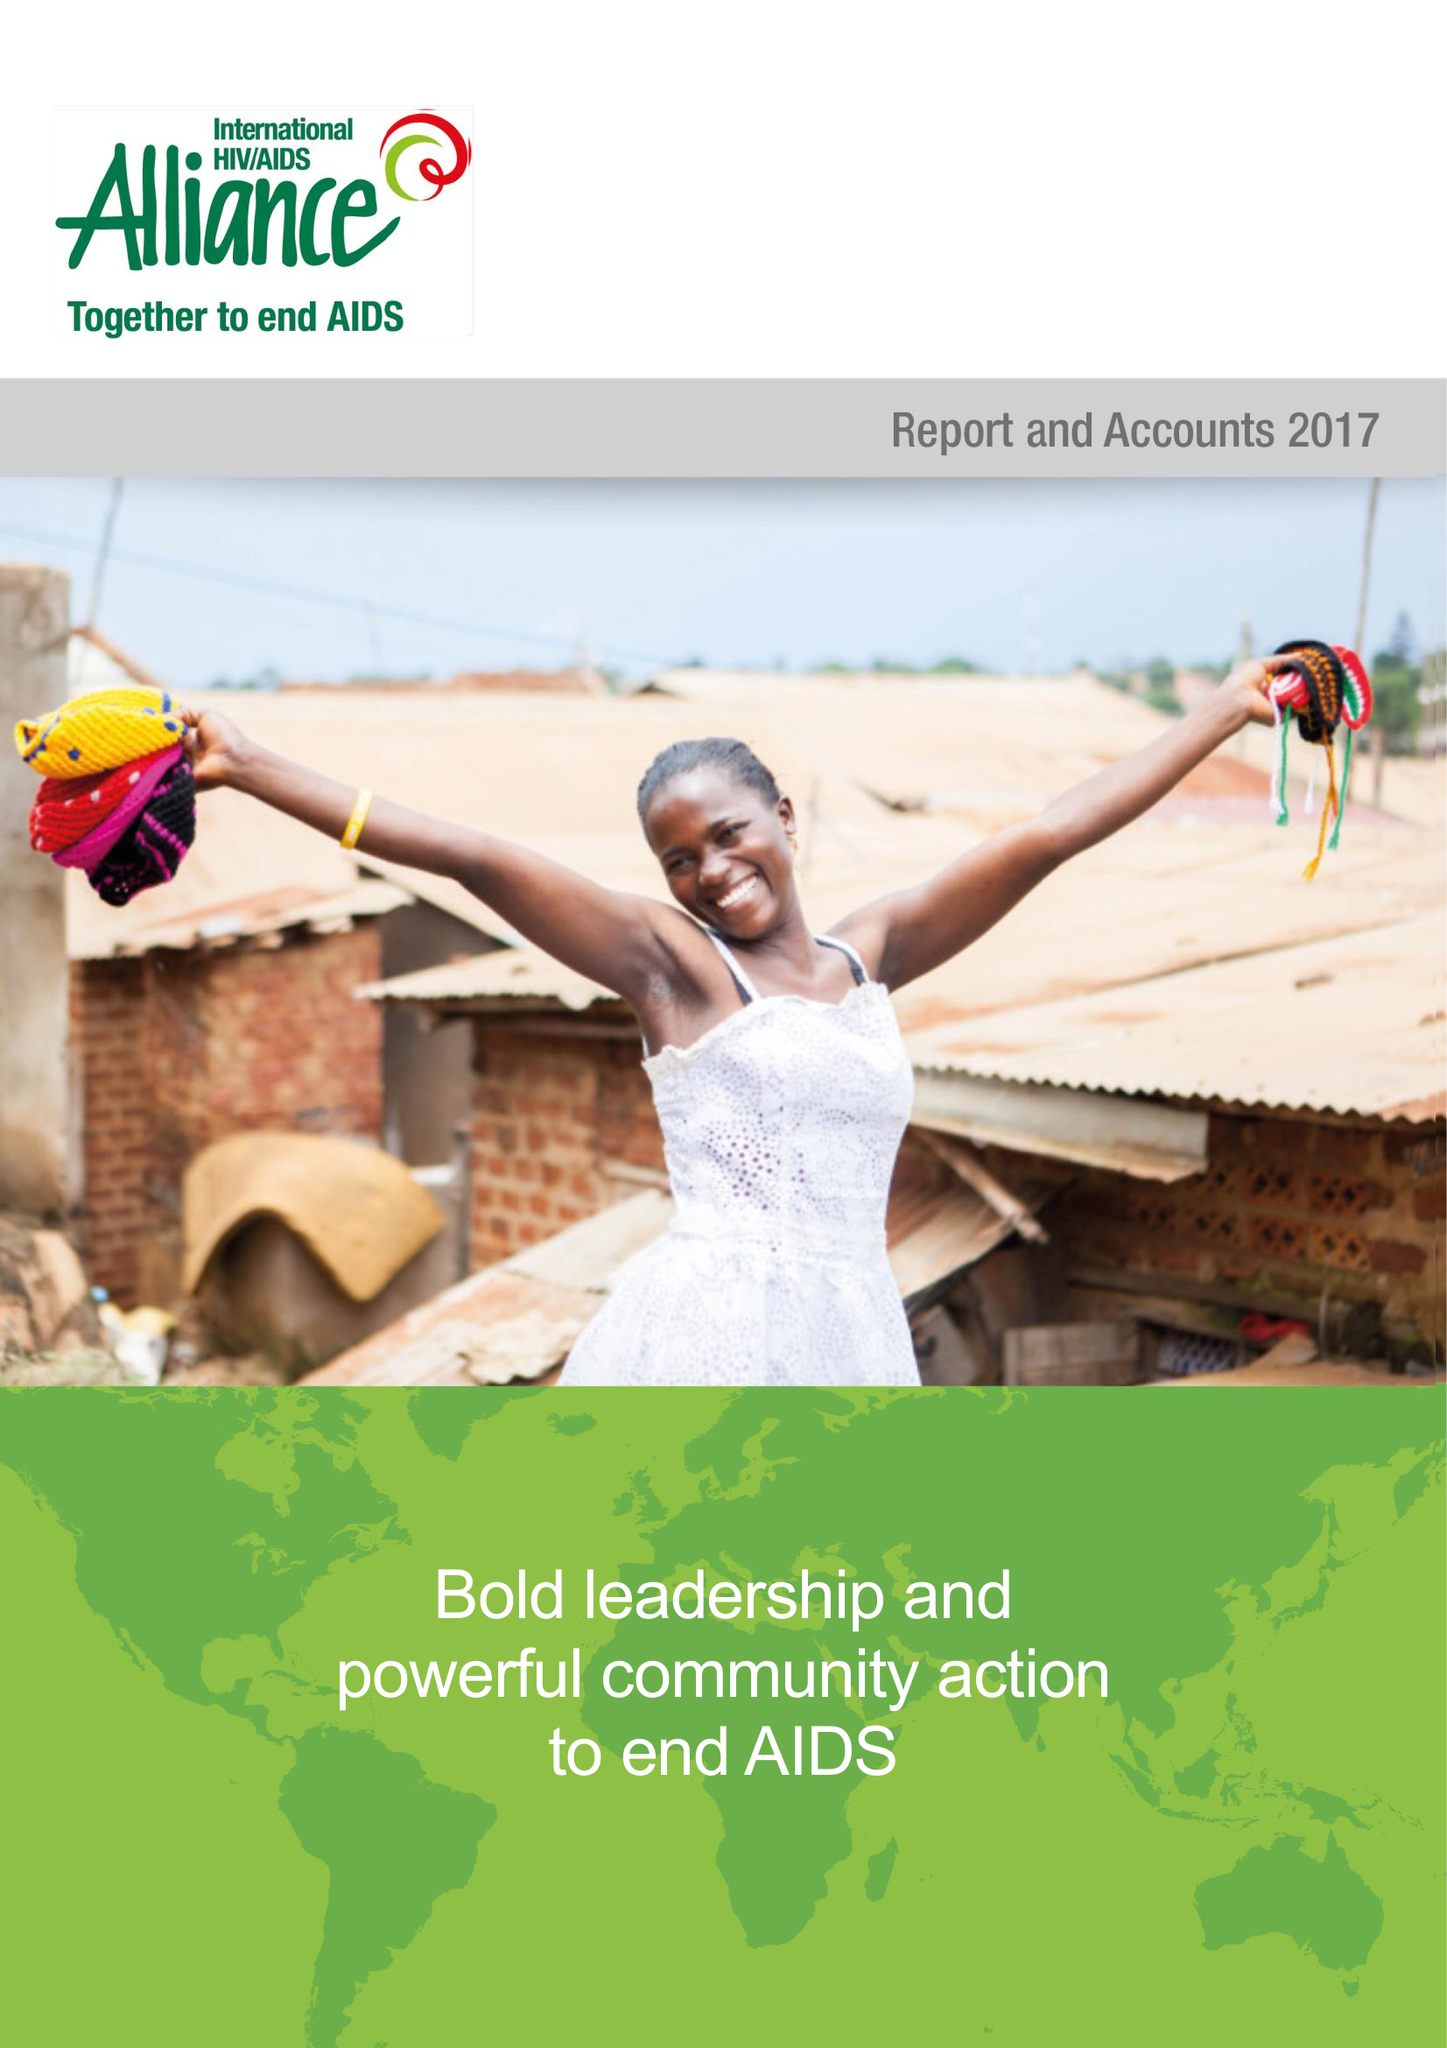What is the value for the address__postcode?
Answer the question using a single word or phrase. BN3 1RE 